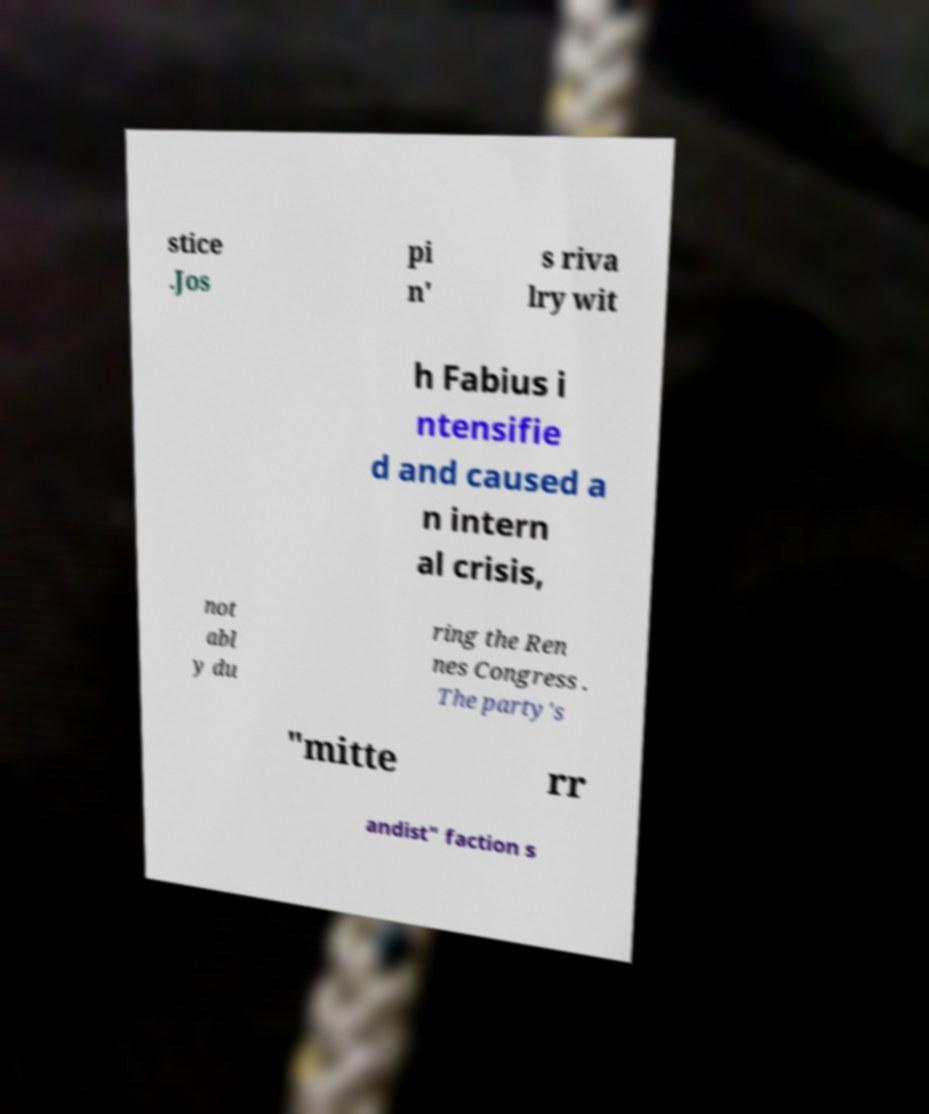What messages or text are displayed in this image? I need them in a readable, typed format. stice .Jos pi n' s riva lry wit h Fabius i ntensifie d and caused a n intern al crisis, not abl y du ring the Ren nes Congress . The party's "mitte rr andist" faction s 